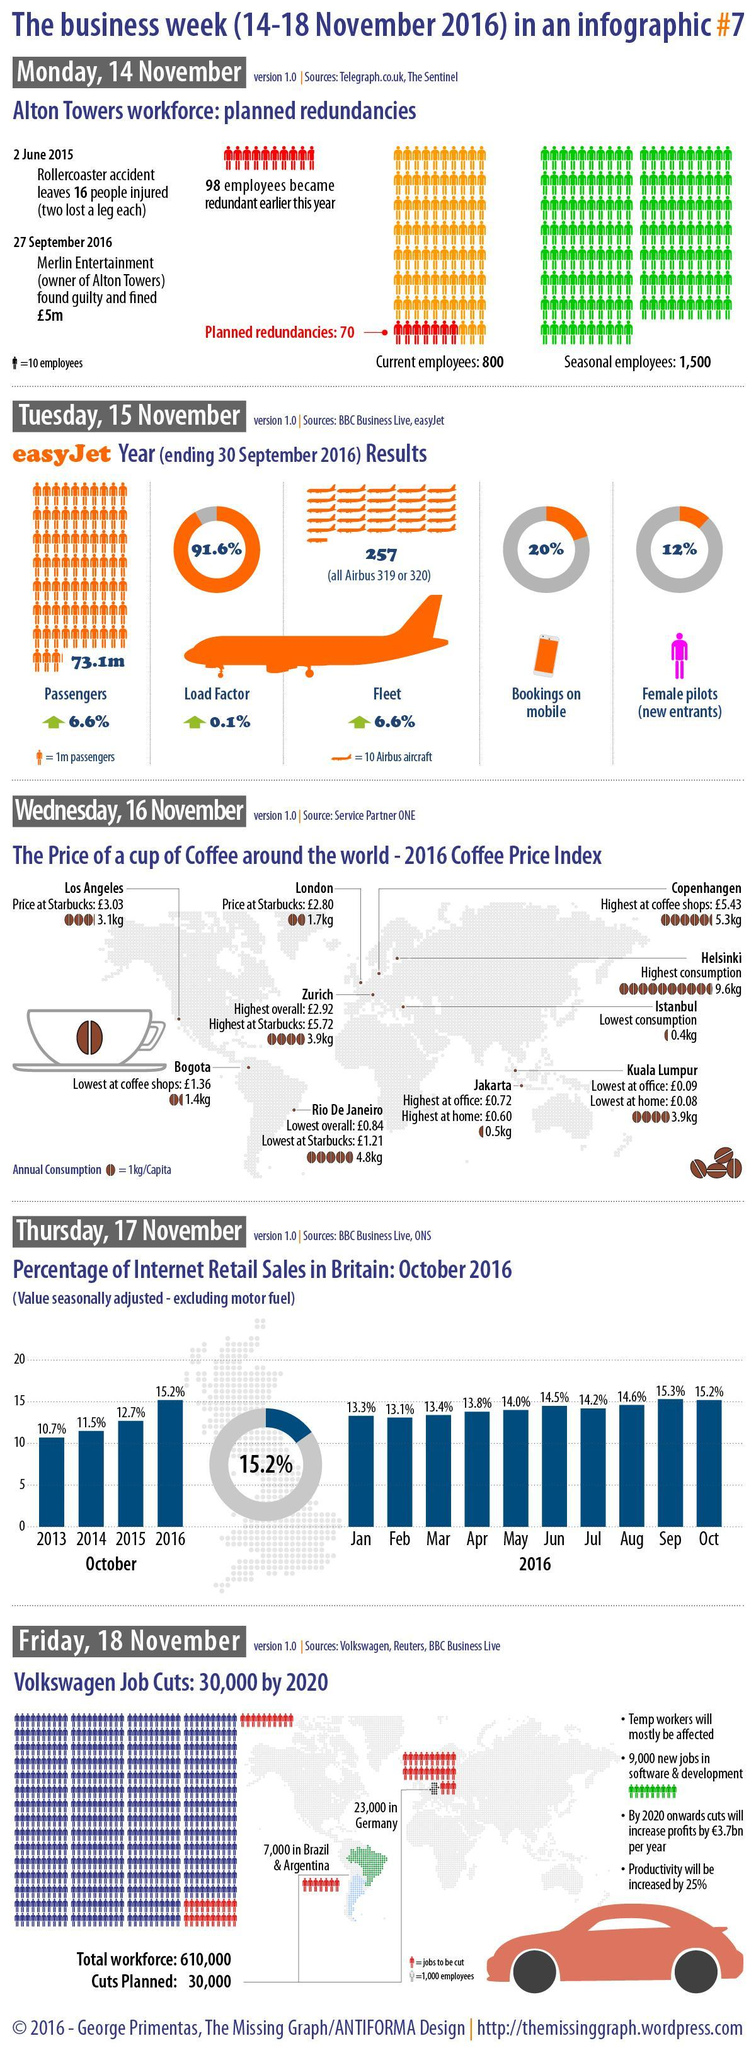What is the percentage of bookings that are not from the mobile?
Answer the question with a short phrase. 80% What is the percentage of internet retail sales in Sep and Oct, taken together? 30.5% In which month the internet retail sales is the highest? Sep What is the percentage of internet retail sales in Mar and Apr, taken together? 27.2% What is the percentage of internet retail sales in 2014 and 2015, taken together? 24.2% What is the percentage of internet retail sales in Jan and Feb, taken together? 26.4% What is the percentage of pilots who are not females? 88% 